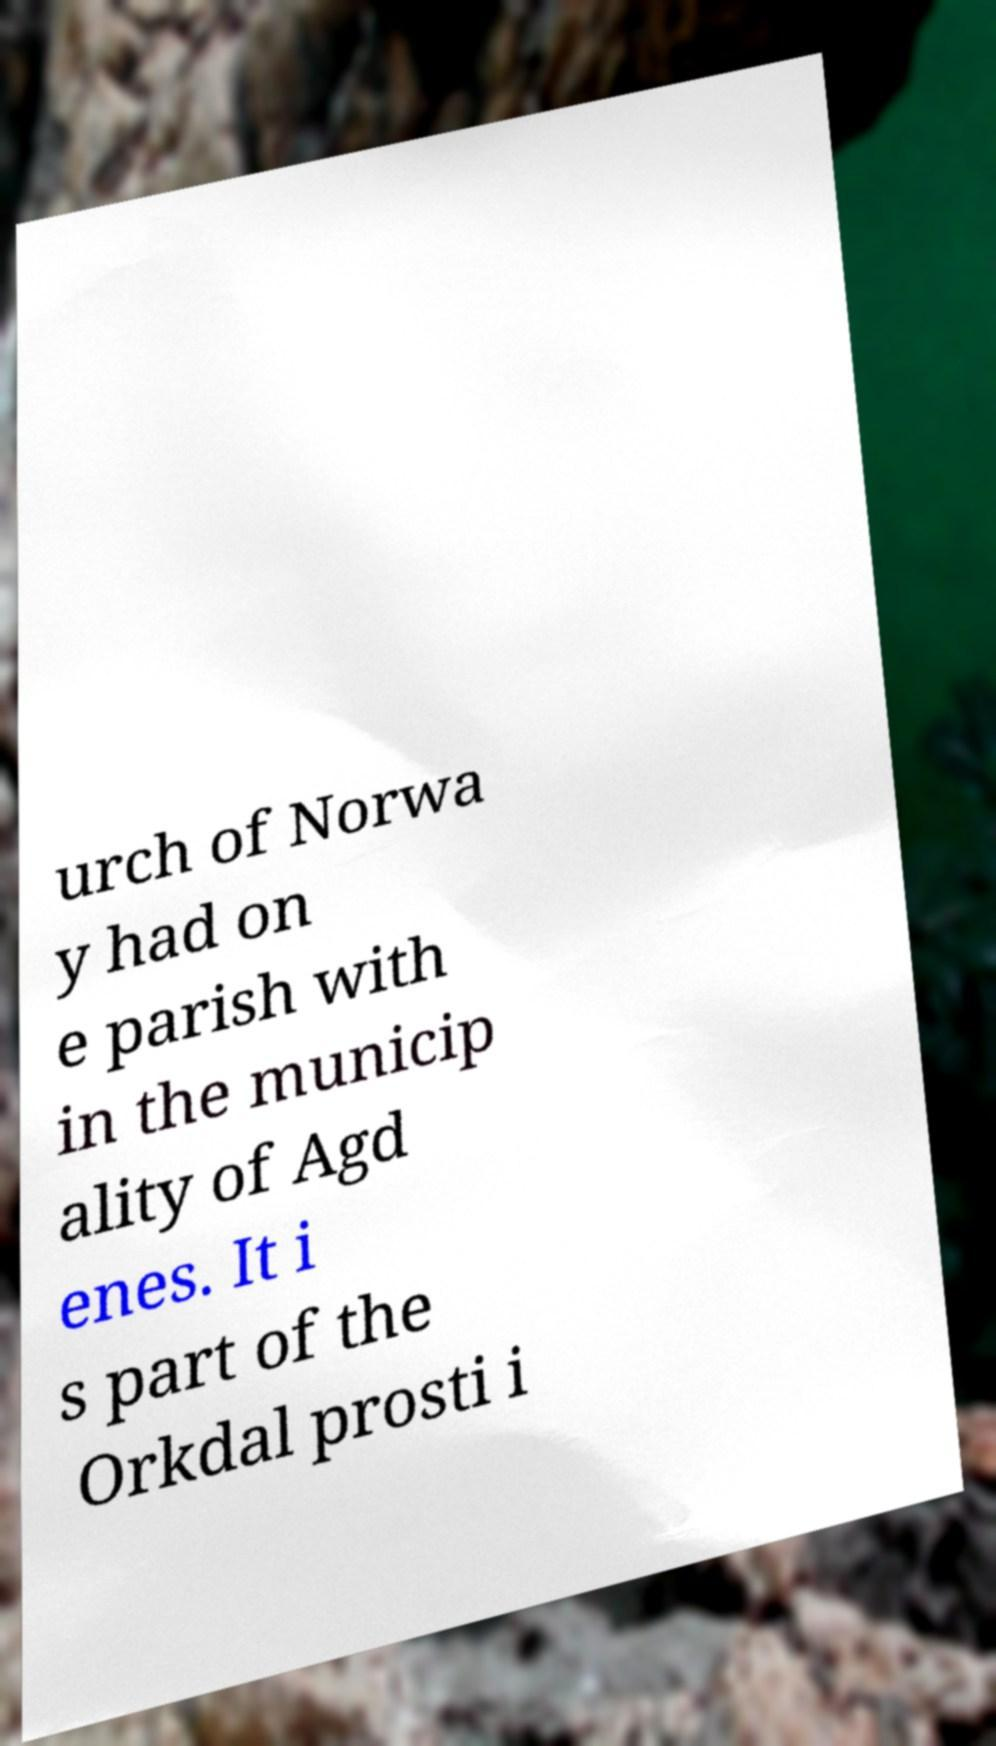Please read and relay the text visible in this image. What does it say? urch of Norwa y had on e parish with in the municip ality of Agd enes. It i s part of the Orkdal prosti i 